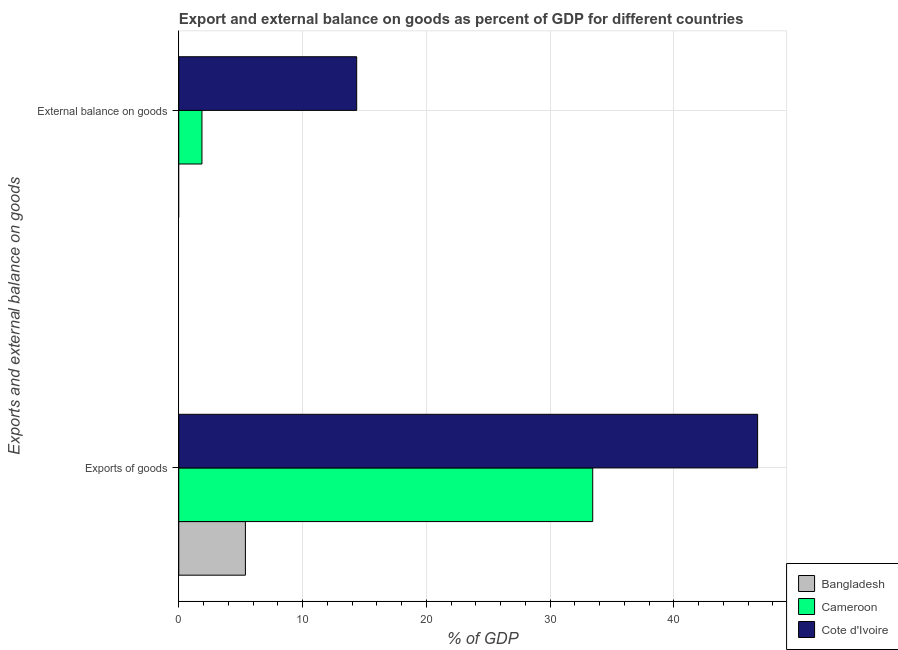How many different coloured bars are there?
Offer a terse response. 3. How many groups of bars are there?
Keep it short and to the point. 2. Are the number of bars per tick equal to the number of legend labels?
Ensure brevity in your answer.  No. How many bars are there on the 1st tick from the bottom?
Provide a succinct answer. 3. What is the label of the 2nd group of bars from the top?
Offer a terse response. Exports of goods. Across all countries, what is the maximum export of goods as percentage of gdp?
Provide a succinct answer. 46.77. Across all countries, what is the minimum export of goods as percentage of gdp?
Offer a terse response. 5.38. In which country was the export of goods as percentage of gdp maximum?
Provide a succinct answer. Cote d'Ivoire. What is the total external balance on goods as percentage of gdp in the graph?
Offer a terse response. 16.25. What is the difference between the export of goods as percentage of gdp in Cote d'Ivoire and that in Bangladesh?
Offer a very short reply. 41.39. What is the difference between the external balance on goods as percentage of gdp in Cameroon and the export of goods as percentage of gdp in Cote d'Ivoire?
Offer a very short reply. -44.9. What is the average export of goods as percentage of gdp per country?
Your answer should be compact. 28.54. What is the difference between the export of goods as percentage of gdp and external balance on goods as percentage of gdp in Cote d'Ivoire?
Provide a short and direct response. 32.4. In how many countries, is the external balance on goods as percentage of gdp greater than 14 %?
Make the answer very short. 1. What is the ratio of the export of goods as percentage of gdp in Cameroon to that in Bangladesh?
Offer a very short reply. 6.21. In how many countries, is the export of goods as percentage of gdp greater than the average export of goods as percentage of gdp taken over all countries?
Provide a succinct answer. 2. Are all the bars in the graph horizontal?
Give a very brief answer. Yes. How many countries are there in the graph?
Keep it short and to the point. 3. Are the values on the major ticks of X-axis written in scientific E-notation?
Make the answer very short. No. Does the graph contain any zero values?
Your answer should be compact. Yes. Does the graph contain grids?
Ensure brevity in your answer.  Yes. What is the title of the graph?
Offer a very short reply. Export and external balance on goods as percent of GDP for different countries. What is the label or title of the X-axis?
Provide a succinct answer. % of GDP. What is the label or title of the Y-axis?
Offer a very short reply. Exports and external balance on goods. What is the % of GDP of Bangladesh in Exports of goods?
Your answer should be compact. 5.38. What is the % of GDP of Cameroon in Exports of goods?
Offer a terse response. 33.45. What is the % of GDP in Cote d'Ivoire in Exports of goods?
Your answer should be compact. 46.77. What is the % of GDP of Bangladesh in External balance on goods?
Offer a terse response. 0. What is the % of GDP of Cameroon in External balance on goods?
Provide a short and direct response. 1.87. What is the % of GDP in Cote d'Ivoire in External balance on goods?
Provide a succinct answer. 14.38. Across all Exports and external balance on goods, what is the maximum % of GDP of Bangladesh?
Provide a succinct answer. 5.38. Across all Exports and external balance on goods, what is the maximum % of GDP in Cameroon?
Provide a succinct answer. 33.45. Across all Exports and external balance on goods, what is the maximum % of GDP of Cote d'Ivoire?
Make the answer very short. 46.77. Across all Exports and external balance on goods, what is the minimum % of GDP in Cameroon?
Ensure brevity in your answer.  1.87. Across all Exports and external balance on goods, what is the minimum % of GDP of Cote d'Ivoire?
Offer a terse response. 14.38. What is the total % of GDP of Bangladesh in the graph?
Offer a terse response. 5.38. What is the total % of GDP of Cameroon in the graph?
Make the answer very short. 35.32. What is the total % of GDP of Cote d'Ivoire in the graph?
Keep it short and to the point. 61.15. What is the difference between the % of GDP of Cameroon in Exports of goods and that in External balance on goods?
Make the answer very short. 31.58. What is the difference between the % of GDP in Cote d'Ivoire in Exports of goods and that in External balance on goods?
Keep it short and to the point. 32.4. What is the difference between the % of GDP in Bangladesh in Exports of goods and the % of GDP in Cameroon in External balance on goods?
Ensure brevity in your answer.  3.51. What is the difference between the % of GDP in Bangladesh in Exports of goods and the % of GDP in Cote d'Ivoire in External balance on goods?
Keep it short and to the point. -8.99. What is the difference between the % of GDP of Cameroon in Exports of goods and the % of GDP of Cote d'Ivoire in External balance on goods?
Provide a succinct answer. 19.07. What is the average % of GDP in Bangladesh per Exports and external balance on goods?
Your answer should be very brief. 2.69. What is the average % of GDP in Cameroon per Exports and external balance on goods?
Your answer should be very brief. 17.66. What is the average % of GDP in Cote d'Ivoire per Exports and external balance on goods?
Keep it short and to the point. 30.58. What is the difference between the % of GDP in Bangladesh and % of GDP in Cameroon in Exports of goods?
Your answer should be compact. -28.06. What is the difference between the % of GDP of Bangladesh and % of GDP of Cote d'Ivoire in Exports of goods?
Your answer should be compact. -41.39. What is the difference between the % of GDP of Cameroon and % of GDP of Cote d'Ivoire in Exports of goods?
Your answer should be compact. -13.33. What is the difference between the % of GDP of Cameroon and % of GDP of Cote d'Ivoire in External balance on goods?
Your answer should be compact. -12.5. What is the ratio of the % of GDP of Cameroon in Exports of goods to that in External balance on goods?
Make the answer very short. 17.86. What is the ratio of the % of GDP of Cote d'Ivoire in Exports of goods to that in External balance on goods?
Your answer should be very brief. 3.25. What is the difference between the highest and the second highest % of GDP of Cameroon?
Ensure brevity in your answer.  31.58. What is the difference between the highest and the second highest % of GDP in Cote d'Ivoire?
Your answer should be very brief. 32.4. What is the difference between the highest and the lowest % of GDP in Bangladesh?
Keep it short and to the point. 5.38. What is the difference between the highest and the lowest % of GDP in Cameroon?
Offer a terse response. 31.58. What is the difference between the highest and the lowest % of GDP in Cote d'Ivoire?
Give a very brief answer. 32.4. 